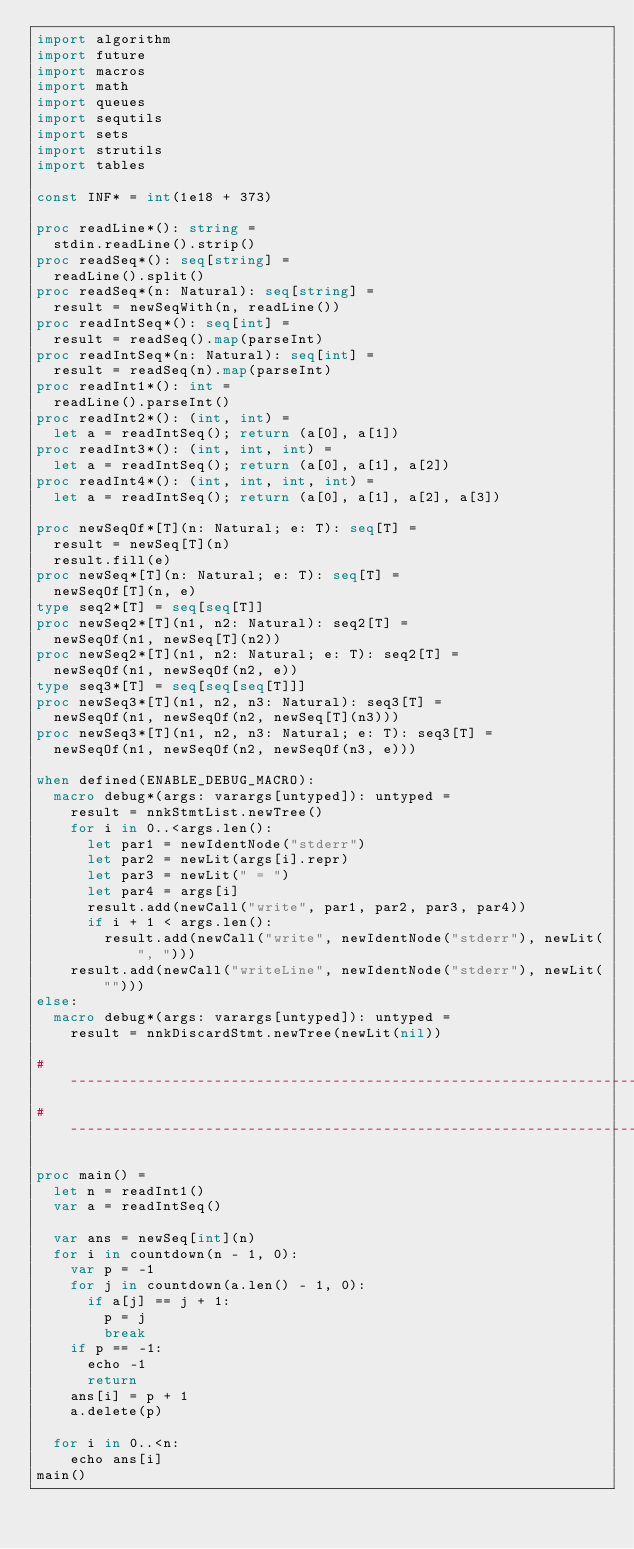Convert code to text. <code><loc_0><loc_0><loc_500><loc_500><_Nim_>import algorithm
import future
import macros
import math
import queues
import sequtils
import sets
import strutils
import tables

const INF* = int(1e18 + 373)

proc readLine*(): string =
  stdin.readLine().strip()
proc readSeq*(): seq[string] =
  readLine().split()
proc readSeq*(n: Natural): seq[string] =
  result = newSeqWith(n, readLine())
proc readIntSeq*(): seq[int] =
  result = readSeq().map(parseInt)
proc readIntSeq*(n: Natural): seq[int] =
  result = readSeq(n).map(parseInt)
proc readInt1*(): int =
  readLine().parseInt()
proc readInt2*(): (int, int) =
  let a = readIntSeq(); return (a[0], a[1])
proc readInt3*(): (int, int, int) =
  let a = readIntSeq(); return (a[0], a[1], a[2])
proc readInt4*(): (int, int, int, int) =
  let a = readIntSeq(); return (a[0], a[1], a[2], a[3])

proc newSeqOf*[T](n: Natural; e: T): seq[T] =
  result = newSeq[T](n)
  result.fill(e)
proc newSeq*[T](n: Natural; e: T): seq[T] =
  newSeqOf[T](n, e)
type seq2*[T] = seq[seq[T]]
proc newSeq2*[T](n1, n2: Natural): seq2[T] =
  newSeqOf(n1, newSeq[T](n2))
proc newSeq2*[T](n1, n2: Natural; e: T): seq2[T] =
  newSeqOf(n1, newSeqOf(n2, e))
type seq3*[T] = seq[seq[seq[T]]]
proc newSeq3*[T](n1, n2, n3: Natural): seq3[T] =
  newSeqOf(n1, newSeqOf(n2, newSeq[T](n3)))
proc newSeq3*[T](n1, n2, n3: Natural; e: T): seq3[T] =
  newSeqOf(n1, newSeqOf(n2, newSeqOf(n3, e)))

when defined(ENABLE_DEBUG_MACRO):
  macro debug*(args: varargs[untyped]): untyped =
    result = nnkStmtList.newTree()
    for i in 0..<args.len():
      let par1 = newIdentNode("stderr")
      let par2 = newLit(args[i].repr)
      let par3 = newLit(" = ")
      let par4 = args[i]
      result.add(newCall("write", par1, par2, par3, par4))
      if i + 1 < args.len():
        result.add(newCall("write", newIdentNode("stderr"), newLit(", ")))
    result.add(newCall("writeLine", newIdentNode("stderr"), newLit("")))
else:
  macro debug*(args: varargs[untyped]): untyped =
    result = nnkDiscardStmt.newTree(newLit(nil))

#------------------------------------------------------------------------------#
#------------------------------------------------------------------------------#

proc main() =
  let n = readInt1()
  var a = readIntSeq()

  var ans = newSeq[int](n)
  for i in countdown(n - 1, 0):
    var p = -1
    for j in countdown(a.len() - 1, 0):
      if a[j] == j + 1:
        p = j
        break
    if p == -1:
      echo -1
      return
    ans[i] = p + 1
    a.delete(p)

  for i in 0..<n:
    echo ans[i]
main()
</code> 